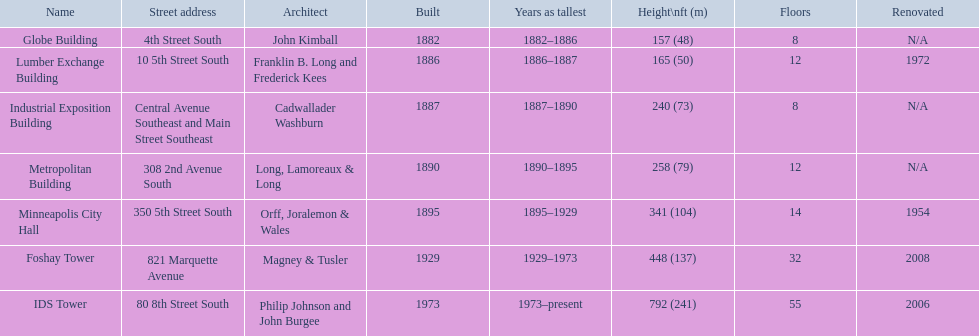Help me parse the entirety of this table. {'header': ['Name', 'Street address', 'Architect', 'Built', 'Years as tallest', 'Height\\nft (m)', 'Floors', 'Renovated'], 'rows': [['Globe Building', '4th Street South', 'John Kimball', '1882', '1882–1886', '157 (48)', '8', 'N/A'], ['Lumber Exchange Building', '10 5th Street South', 'Franklin B. Long and Frederick Kees', '1886', '1886–1887', '165 (50)', '12', '1972'], ['Industrial Exposition Building', 'Central Avenue Southeast and Main Street Southeast', 'Cadwallader Washburn', '1887', '1887–1890', '240 (73)', '8', 'N/A'], ['Metropolitan Building', '308 2nd Avenue South', 'Long, Lamoreaux & Long', '1890', '1890–1895', '258 (79)', '12', 'N/A'], ['Minneapolis City Hall', '350 5th Street South', 'Orff, Joralemon & Wales', '1895', '1895–1929', '341 (104)', '14', '1954'], ['Foshay Tower', '821 Marquette Avenue', 'Magney & Tusler', '1929', '1929–1973', '448 (137)', '32', '2008'], ['IDS Tower', '80 8th Street South', 'Philip Johnson and John Burgee', '1973', '1973–present', '792 (241)', '55', '2006']]} How tall is the metropolitan building? 258 (79). How tall is the lumber exchange building? 165 (50). Is the metropolitan or lumber exchange building taller? Metropolitan Building. 